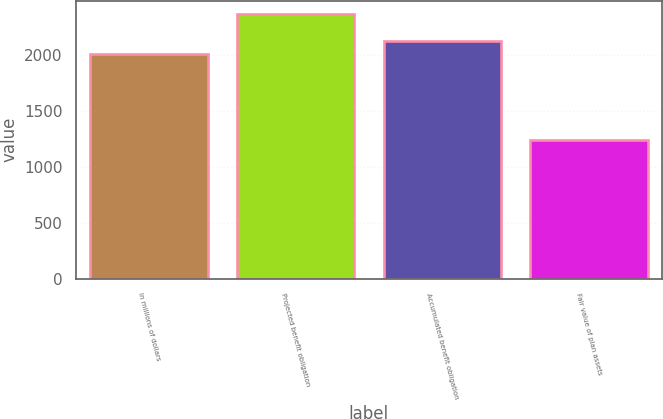Convert chart to OTSL. <chart><loc_0><loc_0><loc_500><loc_500><bar_chart><fcel>In millions of dollars<fcel>Projected benefit obligation<fcel>Accumulated benefit obligation<fcel>Fair value of plan assets<nl><fcel>2015<fcel>2369<fcel>2127.6<fcel>1243<nl></chart> 